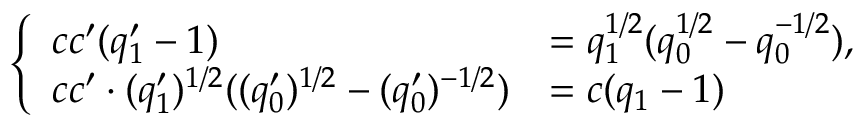Convert formula to latex. <formula><loc_0><loc_0><loc_500><loc_500>\begin{array} { r } { \left \{ \begin{array} { l l } { c c ^ { \prime } ( q _ { 1 } ^ { \prime } - 1 ) } & { = q _ { 1 } ^ { 1 / 2 } ( q _ { 0 } ^ { 1 / 2 } - q _ { 0 } ^ { - 1 / 2 } ) , } \\ { c c ^ { \prime } \cdot ( q _ { 1 } ^ { \prime } ) ^ { 1 / 2 } ( ( q _ { 0 } ^ { \prime } ) ^ { 1 / 2 } - ( q _ { 0 } ^ { \prime } ) ^ { - 1 / 2 } ) } & { = c ( q _ { 1 } - 1 ) } \end{array} } \end{array}</formula> 